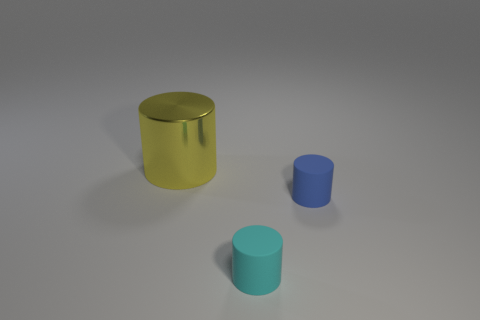Add 1 small blue matte spheres. How many objects exist? 4 Subtract all tiny cylinders. Subtract all metallic cylinders. How many objects are left? 0 Add 3 cyan cylinders. How many cyan cylinders are left? 4 Add 2 big objects. How many big objects exist? 3 Subtract 0 green balls. How many objects are left? 3 